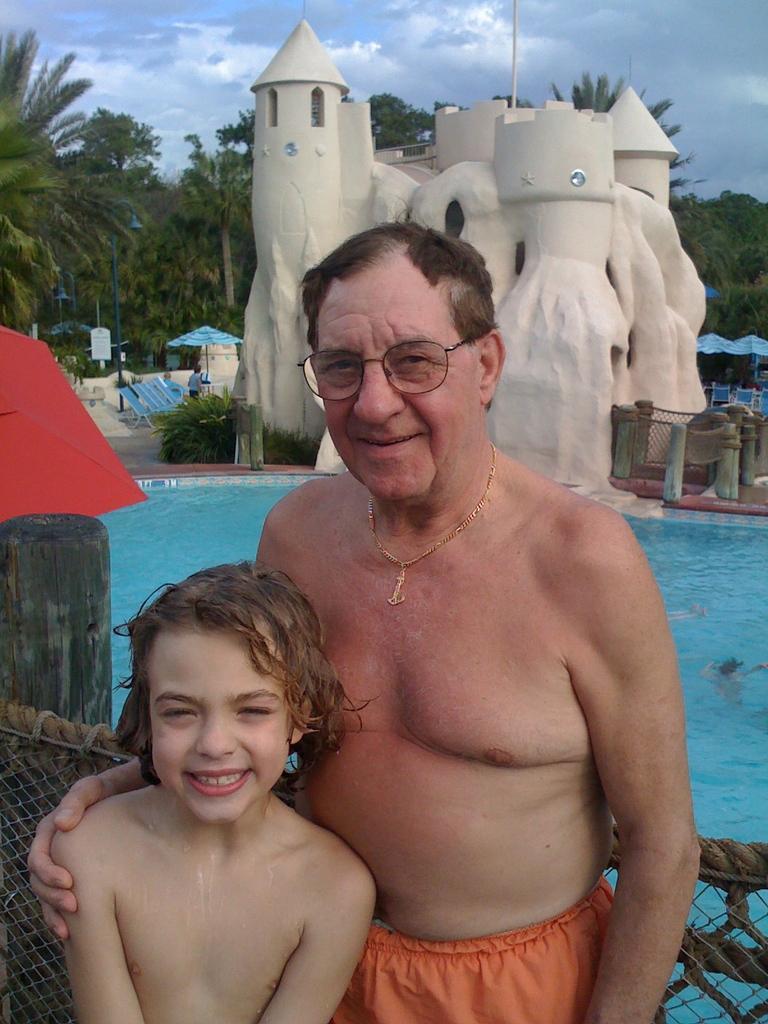Describe this image in one or two sentences. In the center of the image there is a man and kid standing at the pool. In the background there is a castle, water, shack, trees and sky. 